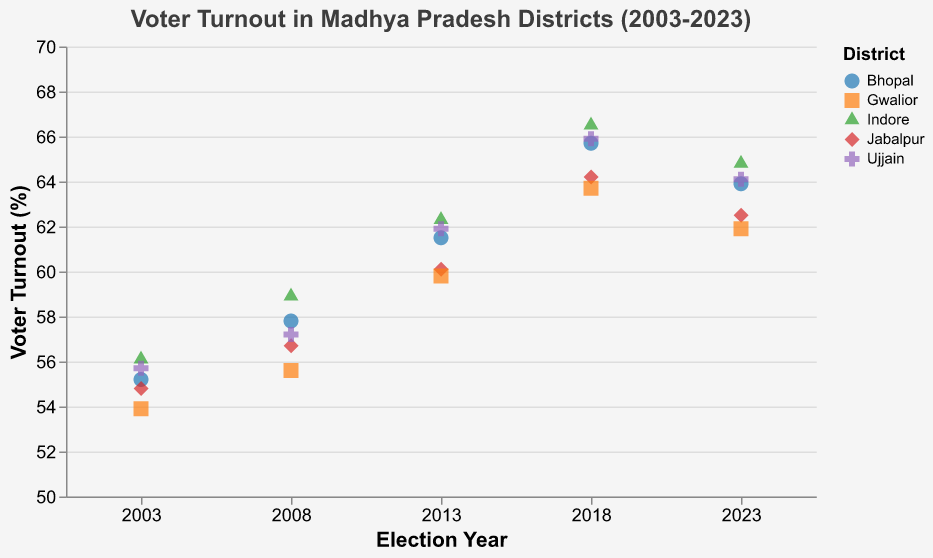What is the title of the plot? The title of the plot is located at the top and it reads "Voter Turnout in Madhya Pradesh Districts (2003-2023)"
Answer: Voter Turnout in Madhya Pradesh Districts (2003-2023) Which district had the highest voter turnout in 2023? By examining the year 2023 on the x-axis and comparing the voter turnout percentages across districts, Indore had the highest voter turnout at 64.8%.
Answer: Indore What is the shape of the data points representing Jabalpur? The shape assigned to Jabalpur is visible in the legend and in the plot itself. Jabalpur is represented by triangle shapes.
Answer: Triangle How did voter turnout in Bhopal change from 2003 to 2023? Looking at the data points for Bhopal across the x-axis from 2003 to 2023, voter turnout increased from 55.2% in 2003 to 63.9% in 2023.
Answer: Increased Which district experienced the highest increase in voter turnout from 2003 to 2018? Find the differences between 2003 and 2018 for all districts: Bhopal (55.2 to 65.7), Indore (56.1 to 66.5), Jabalpur (54.8 to 64.2), Gwalior (53.9 to 63.7), Ujjain (55.7 to 65.9). Indore had the highest increase of 10.4 percentage points.
Answer: Indore What is the voter turnout percentage in Jabalpur for the year 2018? Find Jabalpur on the x-axis for the year 2018, the data point shows a voter turnout of 64.2%.
Answer: 64.2% Compare the voter turnout trend for Ujjain and Gwalior. Gwalior's voter turnout increases from 53.9% in 2003 to 63.7% in 2018, then slightly drops to 61.9% in 2023. Ujjain's turnout increases from 55.7% in 2003 to 65.9% in 2018 and then drops to 64.1% in 2023. Both districts show an increasing trend until 2018, then a slight drop in 2023.
Answer: Both increased till 2018, then slightly dropped In which year did Indore have its highest voter turnout? By checking the points across the years for Indore, the highest voter turnout is observed in 2018 at 66.5%.
Answer: 2018 What is the range of voter turnout percentages shown in the plot? By observing the y-axis from 50% to 70% and analyzing the data points, the lowest turnout is 53.9% in Gwalior (2003) and the highest is 66.5% in Indore (2018). So, the range is from 53.9% to 66.5%.
Answer: 53.9% to 66.5% 